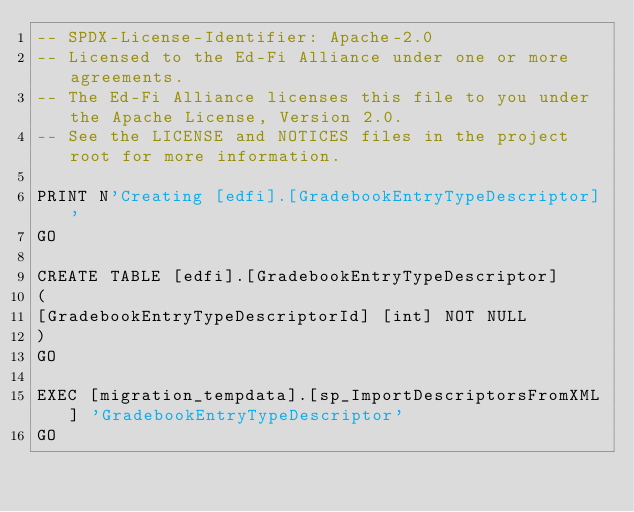<code> <loc_0><loc_0><loc_500><loc_500><_SQL_>-- SPDX-License-Identifier: Apache-2.0
-- Licensed to the Ed-Fi Alliance under one or more agreements.
-- The Ed-Fi Alliance licenses this file to you under the Apache License, Version 2.0.
-- See the LICENSE and NOTICES files in the project root for more information.

PRINT N'Creating [edfi].[GradebookEntryTypeDescriptor]'
GO

CREATE TABLE [edfi].[GradebookEntryTypeDescriptor]
(
[GradebookEntryTypeDescriptorId] [int] NOT NULL
)
GO

EXEC [migration_tempdata].[sp_ImportDescriptorsFromXML] 'GradebookEntryTypeDescriptor'
GO

</code> 